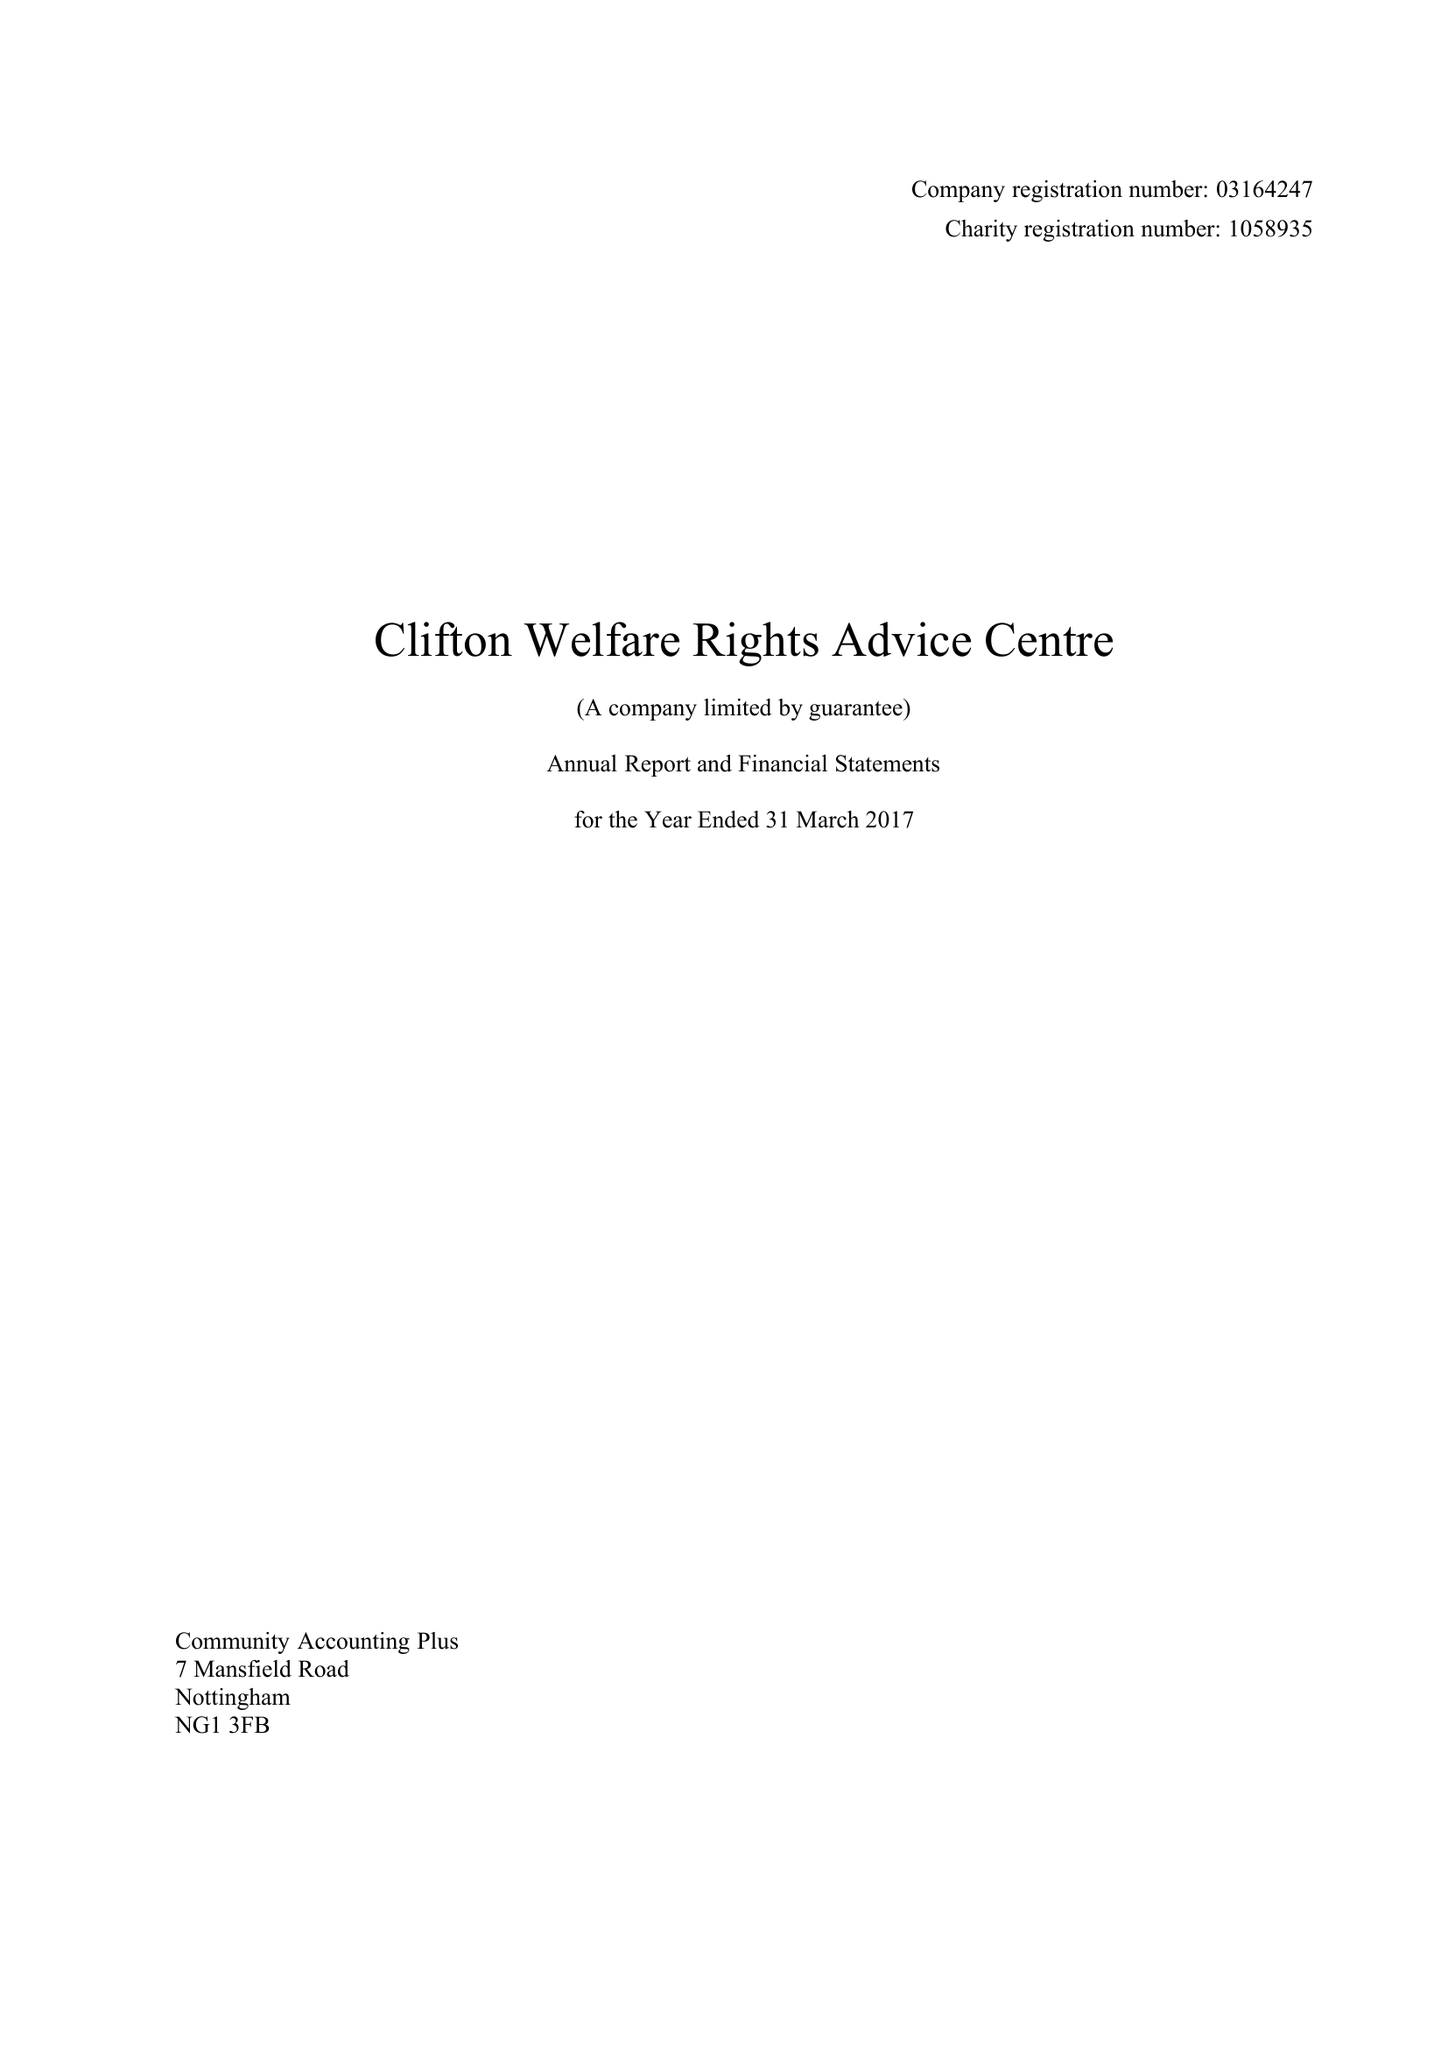What is the value for the address__post_town?
Answer the question using a single word or phrase. NOTTINGHAM 